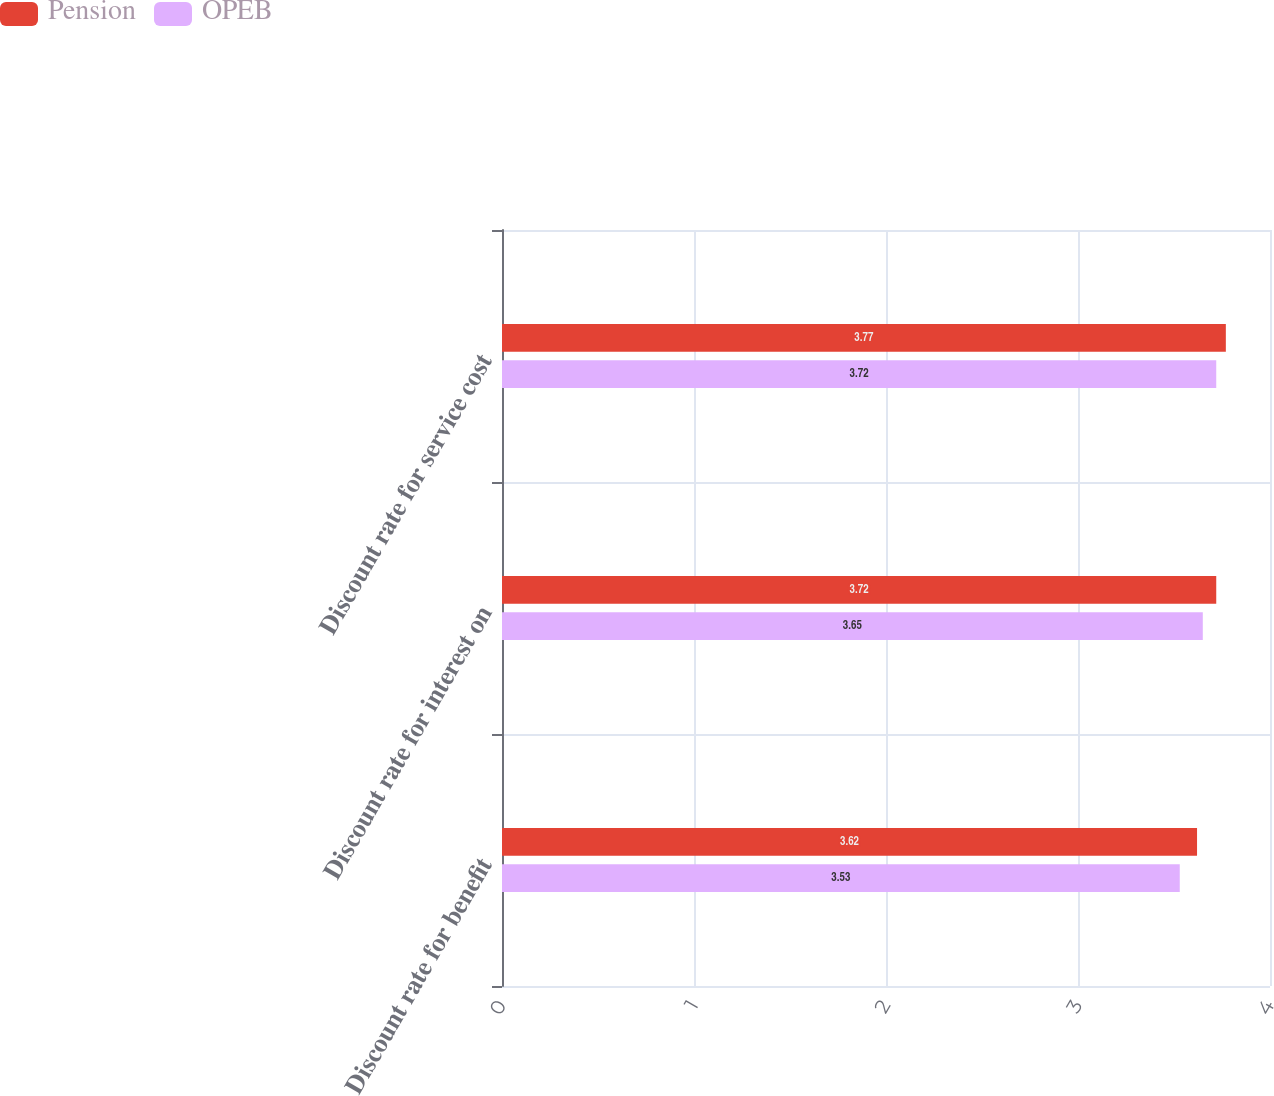Convert chart. <chart><loc_0><loc_0><loc_500><loc_500><stacked_bar_chart><ecel><fcel>Discount rate for benefit<fcel>Discount rate for interest on<fcel>Discount rate for service cost<nl><fcel>Pension<fcel>3.62<fcel>3.72<fcel>3.77<nl><fcel>OPEB<fcel>3.53<fcel>3.65<fcel>3.72<nl></chart> 